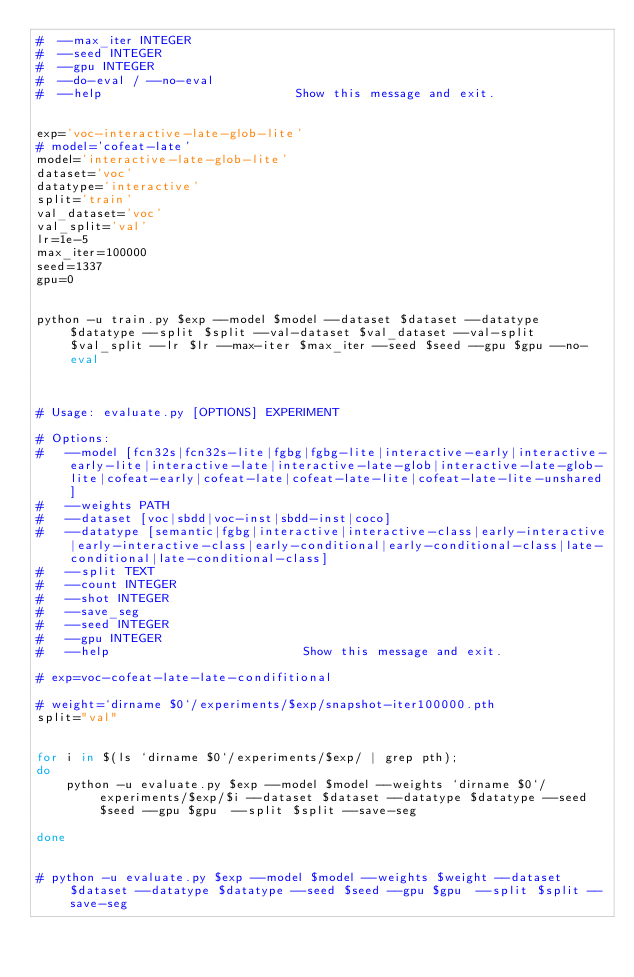<code> <loc_0><loc_0><loc_500><loc_500><_Bash_>#  --max_iter INTEGER
#  --seed INTEGER
#  --gpu INTEGER
#  --do-eval / --no-eval
#  --help                          Show this message and exit.


exp='voc-interactive-late-glob-lite'
# model='cofeat-late'
model='interactive-late-glob-lite'
dataset='voc'
datatype='interactive'
split='train'
val_dataset='voc'
val_split='val'
lr=1e-5
max_iter=100000
seed=1337
gpu=0


python -u train.py $exp --model $model --dataset $dataset --datatype $datatype --split $split --val-dataset $val_dataset --val-split $val_split --lr $lr --max-iter $max_iter --seed $seed --gpu $gpu --no-eval



# Usage: evaluate.py [OPTIONS] EXPERIMENT

# Options:
#   --model [fcn32s|fcn32s-lite|fgbg|fgbg-lite|interactive-early|interactive-early-lite|interactive-late|interactive-late-glob|interactive-late-glob-lite|cofeat-early|cofeat-late|cofeat-late-lite|cofeat-late-lite-unshared]
#   --weights PATH
#   --dataset [voc|sbdd|voc-inst|sbdd-inst|coco]
#   --datatype [semantic|fgbg|interactive|interactive-class|early-interactive|early-interactive-class|early-conditional|early-conditional-class|late-conditional|late-conditional-class]
#   --split TEXT
#   --count INTEGER
#   --shot INTEGER
#   --save_seg
#   --seed INTEGER
#   --gpu INTEGER
#   --help                          Show this message and exit.

# exp=voc-cofeat-late-late-condifitional

# weight=`dirname $0`/experiments/$exp/snapshot-iter100000.pth
split="val"


for i in $(ls `dirname $0`/experiments/$exp/ | grep pth);
do
    python -u evaluate.py $exp --model $model --weights `dirname $0`/experiments/$exp/$i --dataset $dataset --datatype $datatype --seed $seed --gpu $gpu  --split $split --save-seg
    
done


# python -u evaluate.py $exp --model $model --weights $weight --dataset $dataset --datatype $datatype --seed $seed --gpu $gpu  --split $split --save-seg

</code> 